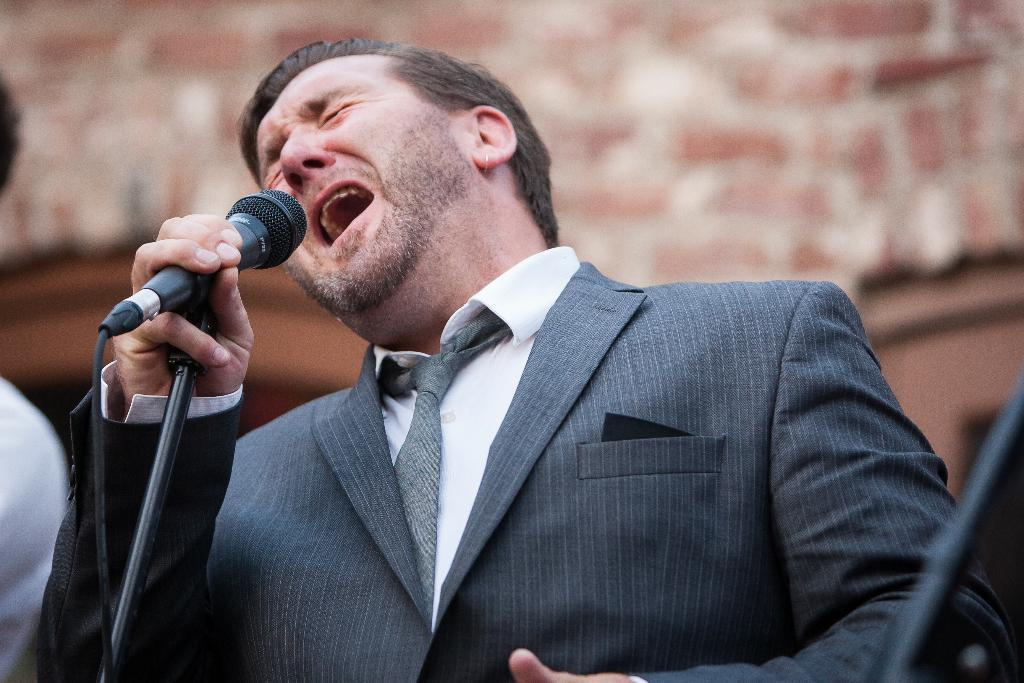What is the main subject of the image? The main subject of the image is a man. What is the man wearing on his upper body? The man is wearing a blue color blazer and a white shirt. Is the man wearing any accessories around his neck? Yes, the man is wearing a tie. What activity is the man engaged in? The man is singing into a microphone. What type of shop can be seen in the background of the image? There is no shop visible in the image; it only features a man singing into a microphone. What is the man's mouth doing while singing into the microphone? The image does not show the man's mouth while singing, so it cannot be determined from the image. 